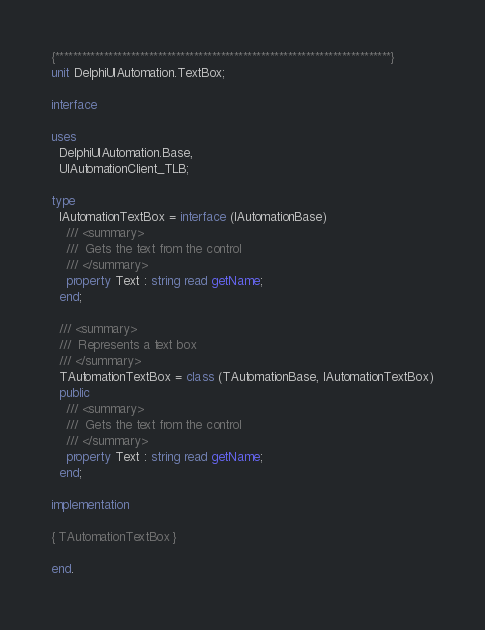<code> <loc_0><loc_0><loc_500><loc_500><_Pascal_>{***************************************************************************}
unit DelphiUIAutomation.TextBox;

interface

uses
  DelphiUIAutomation.Base,
  UIAutomationClient_TLB;

type
  IAutomationTextBox = interface (IAutomationBase)
    /// <summary>
    ///  Gets the text from the control
    /// </summary>
    property Text : string read getName;
  end;

  /// <summary>
  ///  Represents a text box
  /// </summary>
  TAutomationTextBox = class (TAutomationBase, IAutomationTextBox)
  public
    /// <summary>
    ///  Gets the text from the control
    /// </summary>
    property Text : string read getName;
  end;

implementation

{ TAutomationTextBox }

end.
</code> 